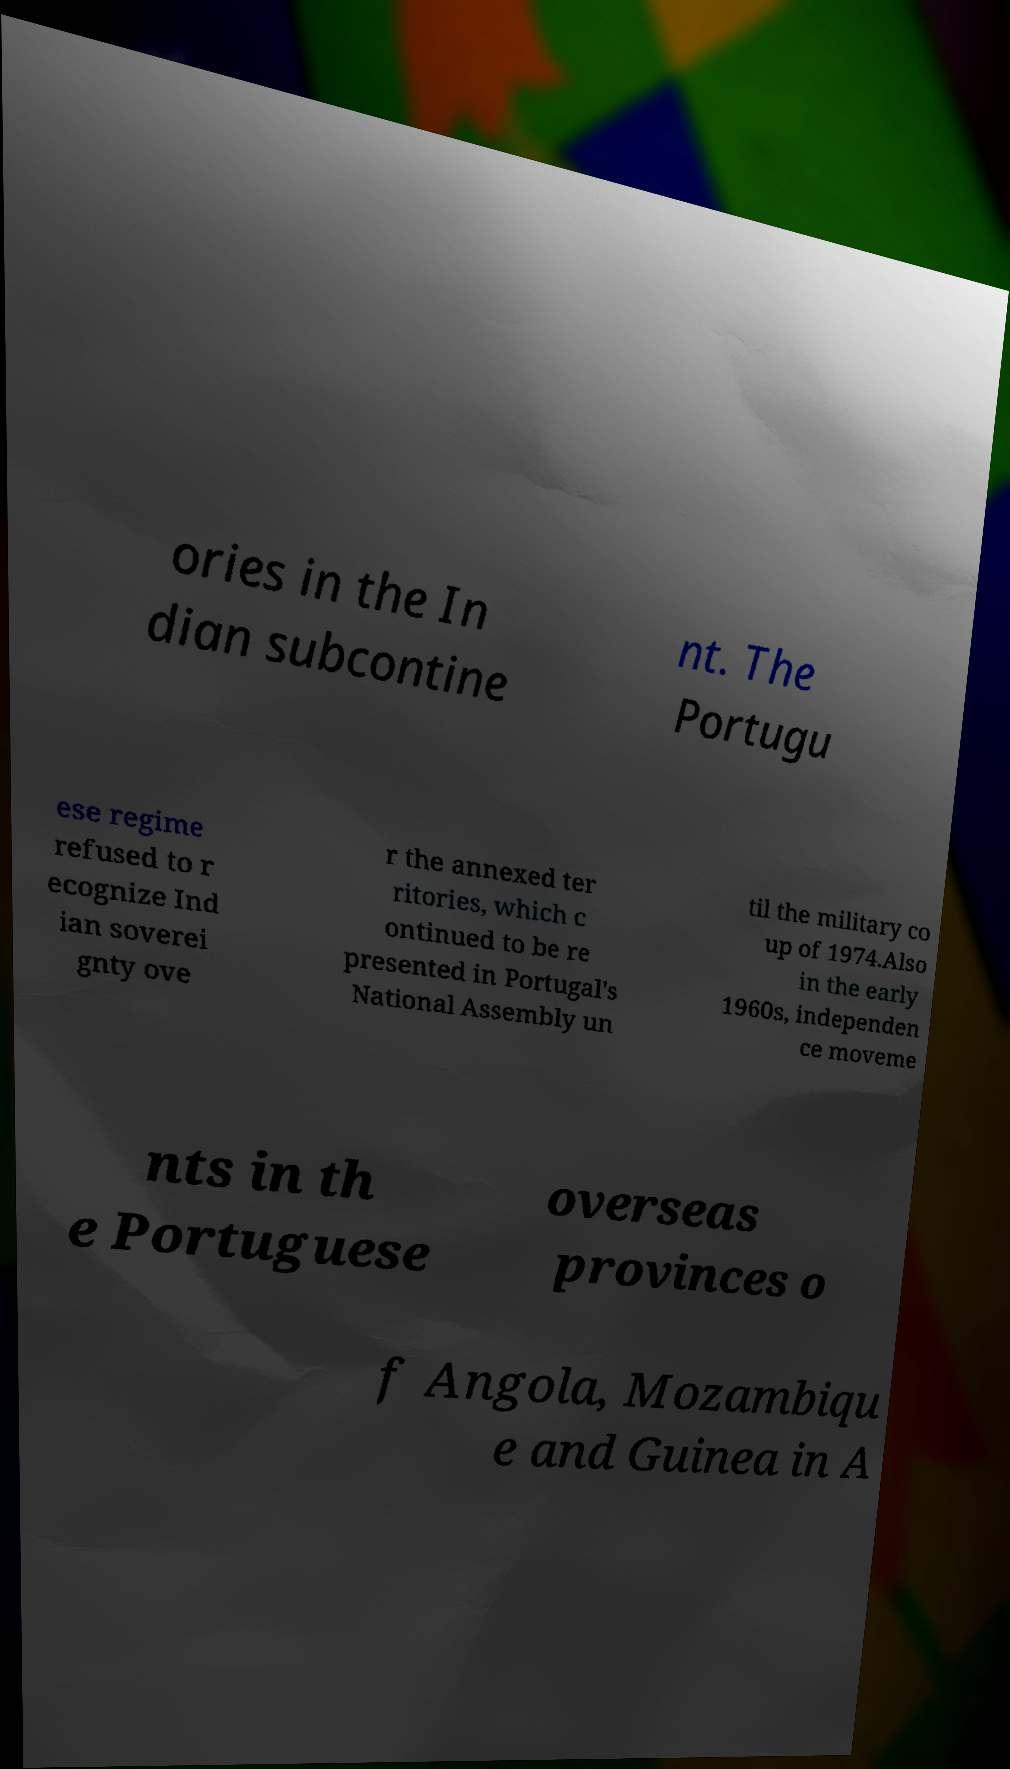Could you extract and type out the text from this image? ories in the In dian subcontine nt. The Portugu ese regime refused to r ecognize Ind ian soverei gnty ove r the annexed ter ritories, which c ontinued to be re presented in Portugal's National Assembly un til the military co up of 1974.Also in the early 1960s, independen ce moveme nts in th e Portuguese overseas provinces o f Angola, Mozambiqu e and Guinea in A 